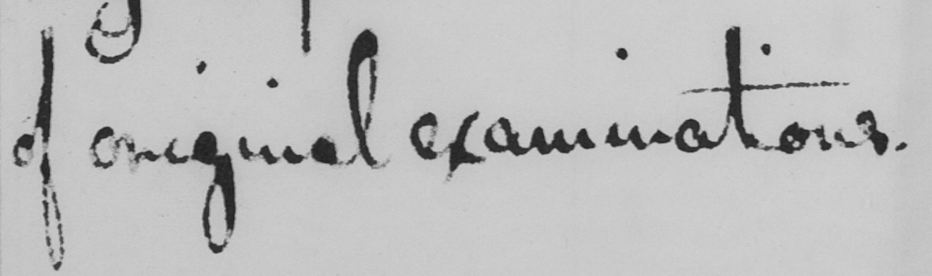Please transcribe the handwritten text in this image. of original examinations . 